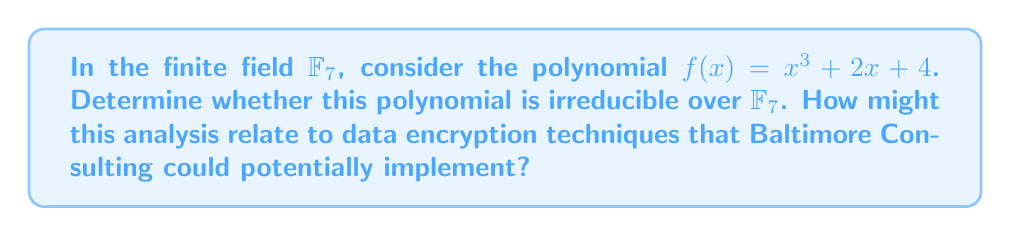Can you solve this math problem? To determine the irreducibility of $f(x) = x^3 + 2x + 4$ over $\mathbb{F}_7$, we'll follow these steps:

1) First, check if $f(x)$ has any linear factors. This means checking if any element of $\mathbb{F}_7$ is a root of $f(x)$.

   For each $a \in \mathbb{F}_7$, compute $f(a)$:
   $f(0) = 4$
   $f(1) = 1 + 2 + 4 = 0$
   $f(2) = 8 + 4 + 4 \equiv 2 \pmod{7}$
   $f(3) = 27 + 6 + 4 \equiv 2 \pmod{7}$
   $f(4) = 64 + 8 + 4 \equiv 6 \pmod{7}$
   $f(5) = 125 + 10 + 4 \equiv 1 \pmod{7}$
   $f(6) = 216 + 12 + 4 \equiv 1 \pmod{7}$

2) We found that $f(1) = 0$, so $(x-1)$ is a factor of $f(x)$.

3) Using polynomial long division or the factor theorem:

   $f(x) = (x-1)(x^2 + x + 5)$

4) The quadratic factor $x^2 + x + 5$ is irreducible over $\mathbb{F}_7$ because it has no roots in $\mathbb{F}_7$ (you can check this by evaluating at each element of $\mathbb{F}_7$).

Therefore, $f(x)$ is reducible over $\mathbb{F}_7$, factoring as the product of a linear and an irreducible quadratic polynomial.

This analysis relates to data encryption as irreducible polynomials over finite fields are crucial in many cryptographic systems, including those based on elliptic curves. Baltimore Consulting could potentially use such polynomials in designing secure communication protocols or in implementing encryption algorithms for their clients' sensitive data.
Answer: Reducible: $f(x) = (x-1)(x^2 + x + 5)$ over $\mathbb{F}_7$ 